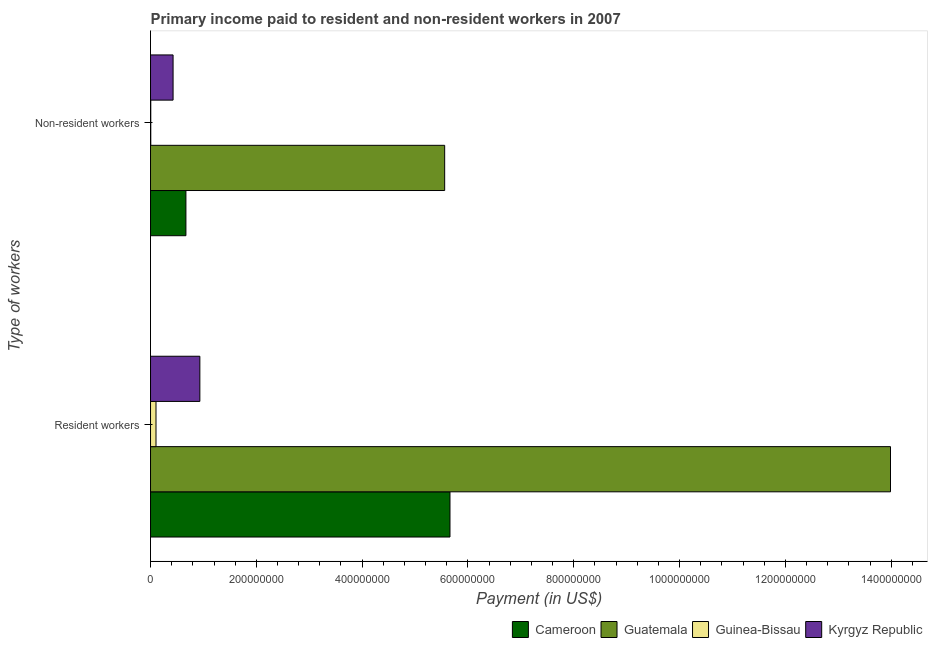How many bars are there on the 2nd tick from the top?
Ensure brevity in your answer.  4. How many bars are there on the 1st tick from the bottom?
Provide a short and direct response. 4. What is the label of the 2nd group of bars from the top?
Ensure brevity in your answer.  Resident workers. What is the payment made to non-resident workers in Cameroon?
Provide a succinct answer. 6.69e+07. Across all countries, what is the maximum payment made to resident workers?
Keep it short and to the point. 1.40e+09. Across all countries, what is the minimum payment made to non-resident workers?
Provide a short and direct response. 4.40e+05. In which country was the payment made to non-resident workers maximum?
Make the answer very short. Guatemala. In which country was the payment made to resident workers minimum?
Give a very brief answer. Guinea-Bissau. What is the total payment made to resident workers in the graph?
Keep it short and to the point. 2.07e+09. What is the difference between the payment made to resident workers in Guatemala and that in Guinea-Bissau?
Your answer should be compact. 1.39e+09. What is the difference between the payment made to resident workers in Guatemala and the payment made to non-resident workers in Guinea-Bissau?
Keep it short and to the point. 1.40e+09. What is the average payment made to non-resident workers per country?
Your response must be concise. 1.66e+08. What is the difference between the payment made to resident workers and payment made to non-resident workers in Cameroon?
Ensure brevity in your answer.  4.99e+08. What is the ratio of the payment made to resident workers in Guinea-Bissau to that in Kyrgyz Republic?
Offer a very short reply. 0.11. Is the payment made to non-resident workers in Kyrgyz Republic less than that in Cameroon?
Make the answer very short. Yes. What does the 4th bar from the top in Non-resident workers represents?
Keep it short and to the point. Cameroon. What does the 2nd bar from the bottom in Non-resident workers represents?
Your answer should be compact. Guatemala. Are all the bars in the graph horizontal?
Offer a terse response. Yes. Are the values on the major ticks of X-axis written in scientific E-notation?
Make the answer very short. No. How many legend labels are there?
Make the answer very short. 4. How are the legend labels stacked?
Provide a succinct answer. Horizontal. What is the title of the graph?
Give a very brief answer. Primary income paid to resident and non-resident workers in 2007. What is the label or title of the X-axis?
Keep it short and to the point. Payment (in US$). What is the label or title of the Y-axis?
Give a very brief answer. Type of workers. What is the Payment (in US$) in Cameroon in Resident workers?
Your answer should be very brief. 5.66e+08. What is the Payment (in US$) of Guatemala in Resident workers?
Your answer should be compact. 1.40e+09. What is the Payment (in US$) of Guinea-Bissau in Resident workers?
Make the answer very short. 1.03e+07. What is the Payment (in US$) of Kyrgyz Republic in Resident workers?
Provide a succinct answer. 9.32e+07. What is the Payment (in US$) of Cameroon in Non-resident workers?
Ensure brevity in your answer.  6.69e+07. What is the Payment (in US$) of Guatemala in Non-resident workers?
Provide a short and direct response. 5.56e+08. What is the Payment (in US$) of Guinea-Bissau in Non-resident workers?
Offer a very short reply. 4.40e+05. What is the Payment (in US$) of Kyrgyz Republic in Non-resident workers?
Provide a succinct answer. 4.26e+07. Across all Type of workers, what is the maximum Payment (in US$) of Cameroon?
Your response must be concise. 5.66e+08. Across all Type of workers, what is the maximum Payment (in US$) of Guatemala?
Your answer should be very brief. 1.40e+09. Across all Type of workers, what is the maximum Payment (in US$) in Guinea-Bissau?
Your answer should be compact. 1.03e+07. Across all Type of workers, what is the maximum Payment (in US$) of Kyrgyz Republic?
Offer a terse response. 9.32e+07. Across all Type of workers, what is the minimum Payment (in US$) of Cameroon?
Offer a very short reply. 6.69e+07. Across all Type of workers, what is the minimum Payment (in US$) of Guatemala?
Your answer should be compact. 5.56e+08. Across all Type of workers, what is the minimum Payment (in US$) in Guinea-Bissau?
Your response must be concise. 4.40e+05. Across all Type of workers, what is the minimum Payment (in US$) in Kyrgyz Republic?
Provide a succinct answer. 4.26e+07. What is the total Payment (in US$) of Cameroon in the graph?
Your response must be concise. 6.33e+08. What is the total Payment (in US$) of Guatemala in the graph?
Your answer should be very brief. 1.95e+09. What is the total Payment (in US$) of Guinea-Bissau in the graph?
Provide a succinct answer. 1.08e+07. What is the total Payment (in US$) in Kyrgyz Republic in the graph?
Your answer should be very brief. 1.36e+08. What is the difference between the Payment (in US$) in Cameroon in Resident workers and that in Non-resident workers?
Make the answer very short. 4.99e+08. What is the difference between the Payment (in US$) in Guatemala in Resident workers and that in Non-resident workers?
Provide a succinct answer. 8.43e+08. What is the difference between the Payment (in US$) in Guinea-Bissau in Resident workers and that in Non-resident workers?
Offer a very short reply. 9.90e+06. What is the difference between the Payment (in US$) in Kyrgyz Republic in Resident workers and that in Non-resident workers?
Your answer should be compact. 5.06e+07. What is the difference between the Payment (in US$) in Cameroon in Resident workers and the Payment (in US$) in Guatemala in Non-resident workers?
Make the answer very short. 1.00e+07. What is the difference between the Payment (in US$) in Cameroon in Resident workers and the Payment (in US$) in Guinea-Bissau in Non-resident workers?
Your answer should be very brief. 5.66e+08. What is the difference between the Payment (in US$) of Cameroon in Resident workers and the Payment (in US$) of Kyrgyz Republic in Non-resident workers?
Provide a short and direct response. 5.23e+08. What is the difference between the Payment (in US$) in Guatemala in Resident workers and the Payment (in US$) in Guinea-Bissau in Non-resident workers?
Your response must be concise. 1.40e+09. What is the difference between the Payment (in US$) in Guatemala in Resident workers and the Payment (in US$) in Kyrgyz Republic in Non-resident workers?
Your answer should be very brief. 1.36e+09. What is the difference between the Payment (in US$) of Guinea-Bissau in Resident workers and the Payment (in US$) of Kyrgyz Republic in Non-resident workers?
Your response must be concise. -3.23e+07. What is the average Payment (in US$) of Cameroon per Type of workers?
Make the answer very short. 3.16e+08. What is the average Payment (in US$) in Guatemala per Type of workers?
Offer a very short reply. 9.77e+08. What is the average Payment (in US$) of Guinea-Bissau per Type of workers?
Offer a very short reply. 5.39e+06. What is the average Payment (in US$) in Kyrgyz Republic per Type of workers?
Offer a terse response. 6.79e+07. What is the difference between the Payment (in US$) in Cameroon and Payment (in US$) in Guatemala in Resident workers?
Make the answer very short. -8.33e+08. What is the difference between the Payment (in US$) in Cameroon and Payment (in US$) in Guinea-Bissau in Resident workers?
Offer a very short reply. 5.56e+08. What is the difference between the Payment (in US$) in Cameroon and Payment (in US$) in Kyrgyz Republic in Resident workers?
Your response must be concise. 4.73e+08. What is the difference between the Payment (in US$) of Guatemala and Payment (in US$) of Guinea-Bissau in Resident workers?
Offer a terse response. 1.39e+09. What is the difference between the Payment (in US$) in Guatemala and Payment (in US$) in Kyrgyz Republic in Resident workers?
Ensure brevity in your answer.  1.31e+09. What is the difference between the Payment (in US$) in Guinea-Bissau and Payment (in US$) in Kyrgyz Republic in Resident workers?
Your answer should be compact. -8.29e+07. What is the difference between the Payment (in US$) in Cameroon and Payment (in US$) in Guatemala in Non-resident workers?
Make the answer very short. -4.89e+08. What is the difference between the Payment (in US$) in Cameroon and Payment (in US$) in Guinea-Bissau in Non-resident workers?
Your answer should be very brief. 6.64e+07. What is the difference between the Payment (in US$) in Cameroon and Payment (in US$) in Kyrgyz Republic in Non-resident workers?
Provide a short and direct response. 2.43e+07. What is the difference between the Payment (in US$) in Guatemala and Payment (in US$) in Guinea-Bissau in Non-resident workers?
Provide a short and direct response. 5.56e+08. What is the difference between the Payment (in US$) in Guatemala and Payment (in US$) in Kyrgyz Republic in Non-resident workers?
Provide a succinct answer. 5.13e+08. What is the difference between the Payment (in US$) in Guinea-Bissau and Payment (in US$) in Kyrgyz Republic in Non-resident workers?
Make the answer very short. -4.22e+07. What is the ratio of the Payment (in US$) in Cameroon in Resident workers to that in Non-resident workers?
Give a very brief answer. 8.46. What is the ratio of the Payment (in US$) of Guatemala in Resident workers to that in Non-resident workers?
Make the answer very short. 2.52. What is the ratio of the Payment (in US$) in Guinea-Bissau in Resident workers to that in Non-resident workers?
Ensure brevity in your answer.  23.5. What is the ratio of the Payment (in US$) in Kyrgyz Republic in Resident workers to that in Non-resident workers?
Make the answer very short. 2.19. What is the difference between the highest and the second highest Payment (in US$) in Cameroon?
Your answer should be very brief. 4.99e+08. What is the difference between the highest and the second highest Payment (in US$) of Guatemala?
Offer a terse response. 8.43e+08. What is the difference between the highest and the second highest Payment (in US$) in Guinea-Bissau?
Ensure brevity in your answer.  9.90e+06. What is the difference between the highest and the second highest Payment (in US$) of Kyrgyz Republic?
Provide a succinct answer. 5.06e+07. What is the difference between the highest and the lowest Payment (in US$) of Cameroon?
Ensure brevity in your answer.  4.99e+08. What is the difference between the highest and the lowest Payment (in US$) of Guatemala?
Provide a succinct answer. 8.43e+08. What is the difference between the highest and the lowest Payment (in US$) in Guinea-Bissau?
Your answer should be compact. 9.90e+06. What is the difference between the highest and the lowest Payment (in US$) in Kyrgyz Republic?
Ensure brevity in your answer.  5.06e+07. 